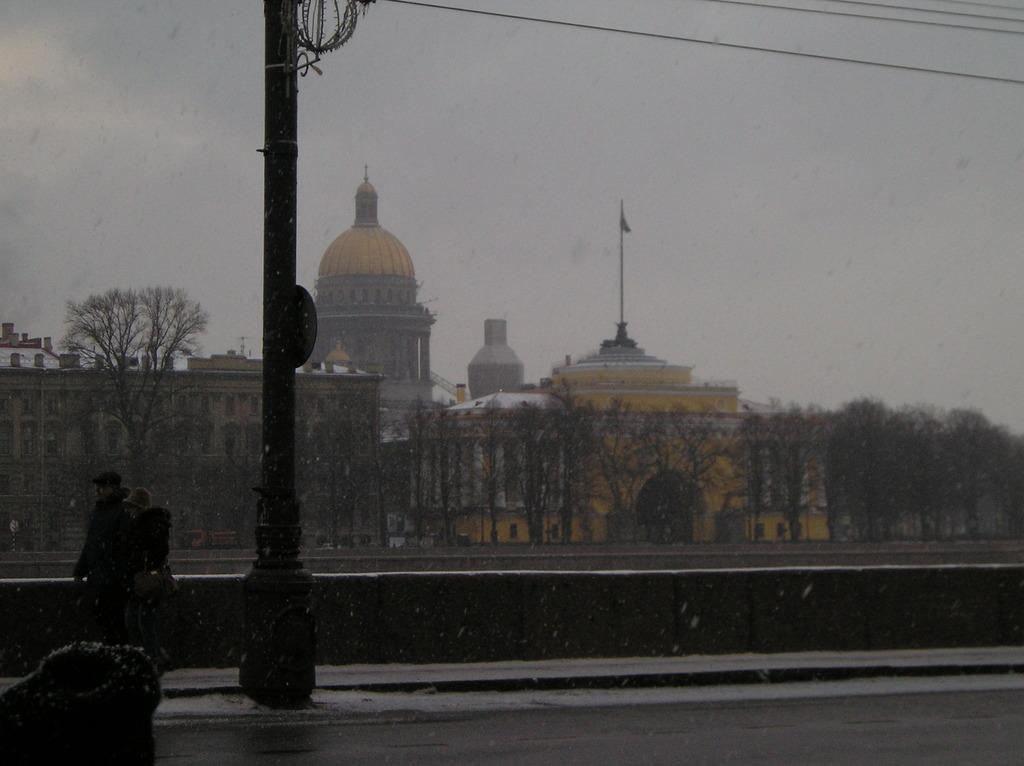What is the main object in the image? There is a pole in the image. What else can be seen in the image besides the pole? There are persons, trees, buildings, and a flag in the image. What is the background of the image like? The sky is visible in the background of the image, and there are clouds present. What type of suit is the person wearing in the image? There is no person wearing a suit in the image. What kind of work is being done by the person in the image? There is no person performing any work in the image. 